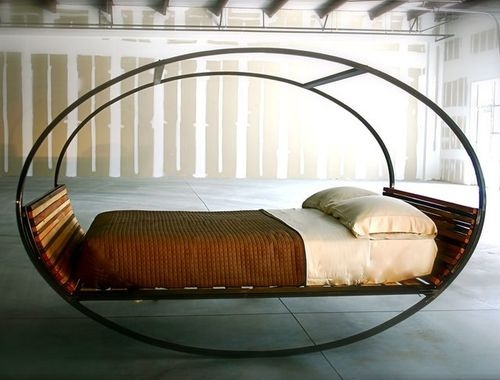Describe the objects in this image and their specific colors. I can see a bed in black, maroon, tan, and beige tones in this image. 